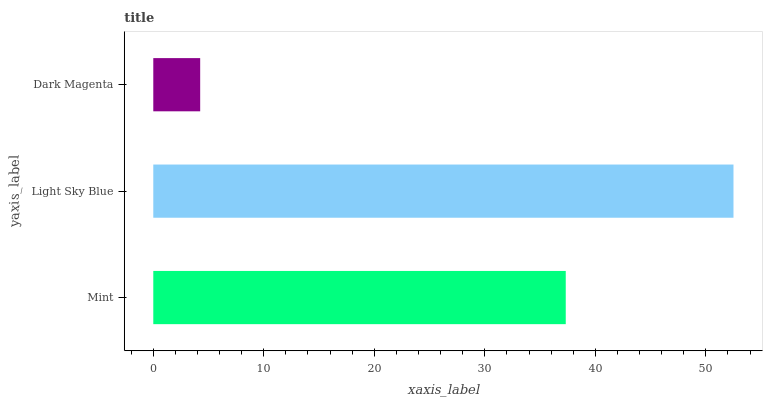Is Dark Magenta the minimum?
Answer yes or no. Yes. Is Light Sky Blue the maximum?
Answer yes or no. Yes. Is Light Sky Blue the minimum?
Answer yes or no. No. Is Dark Magenta the maximum?
Answer yes or no. No. Is Light Sky Blue greater than Dark Magenta?
Answer yes or no. Yes. Is Dark Magenta less than Light Sky Blue?
Answer yes or no. Yes. Is Dark Magenta greater than Light Sky Blue?
Answer yes or no. No. Is Light Sky Blue less than Dark Magenta?
Answer yes or no. No. Is Mint the high median?
Answer yes or no. Yes. Is Mint the low median?
Answer yes or no. Yes. Is Dark Magenta the high median?
Answer yes or no. No. Is Light Sky Blue the low median?
Answer yes or no. No. 